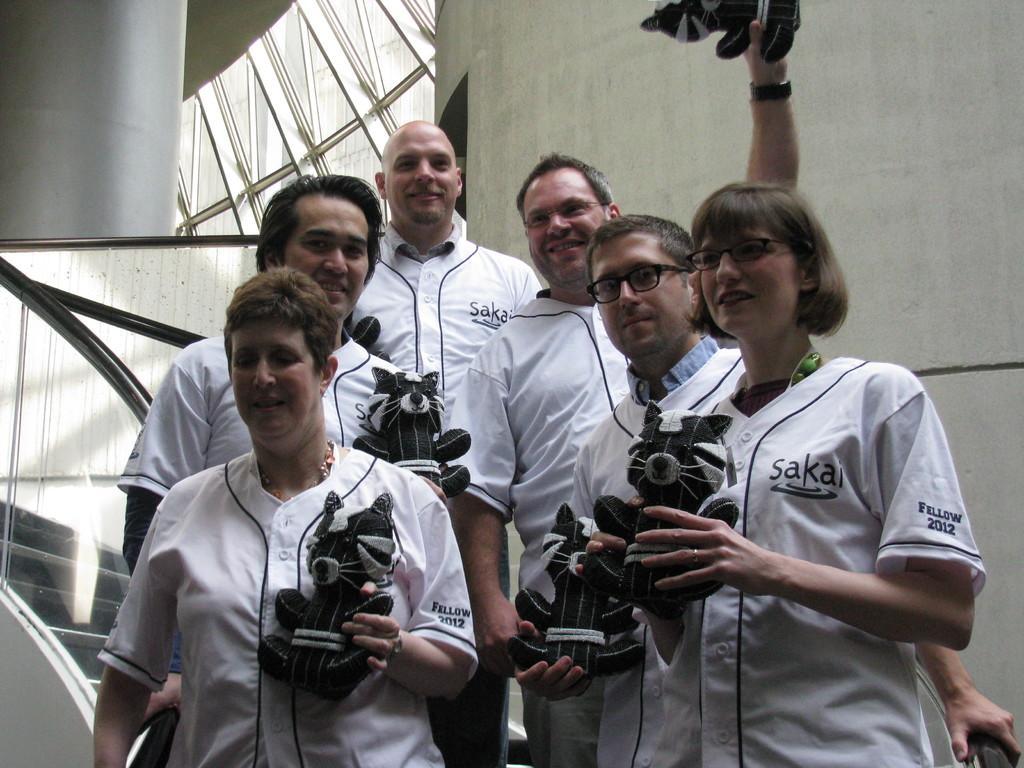In one or two sentences, can you explain what this image depicts? In the image we can see there are people standing wearing clothes and holding a doll in their hands. This two of them are wearing spectacles. This is a neck chain, finger ring, wrist watch stairs and a fence. 